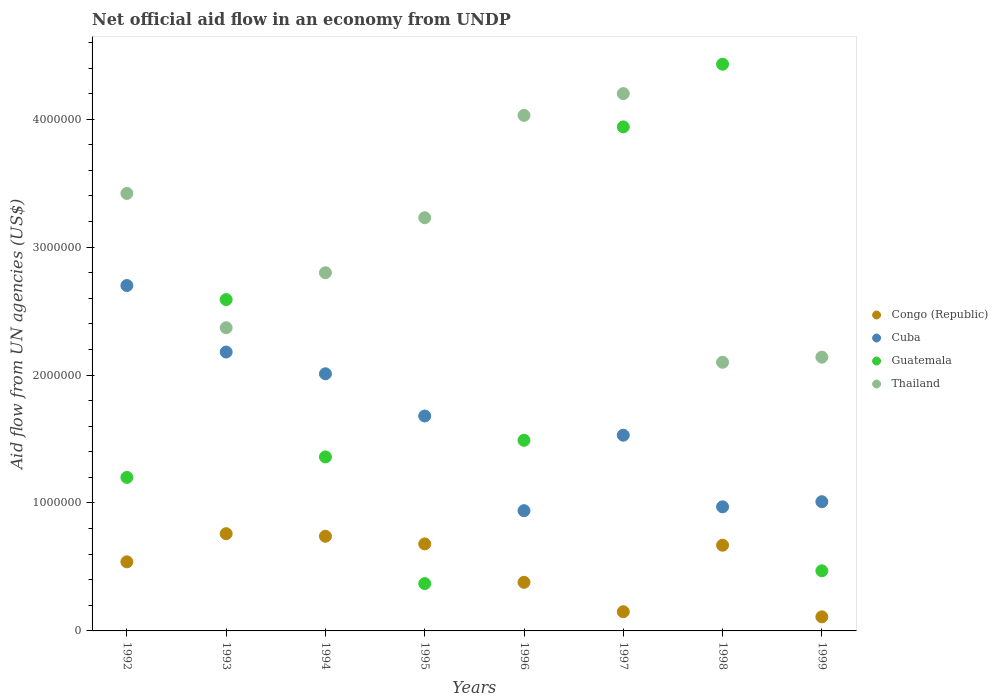How many different coloured dotlines are there?
Your answer should be very brief. 4. What is the net official aid flow in Cuba in 1992?
Offer a very short reply. 2.70e+06. Across all years, what is the maximum net official aid flow in Cuba?
Your answer should be very brief. 2.70e+06. Across all years, what is the minimum net official aid flow in Thailand?
Offer a very short reply. 2.10e+06. In which year was the net official aid flow in Guatemala maximum?
Provide a succinct answer. 1998. What is the total net official aid flow in Guatemala in the graph?
Provide a succinct answer. 1.58e+07. What is the difference between the net official aid flow in Cuba in 1998 and that in 1999?
Ensure brevity in your answer.  -4.00e+04. What is the difference between the net official aid flow in Congo (Republic) in 1992 and the net official aid flow in Thailand in 1997?
Make the answer very short. -3.66e+06. What is the average net official aid flow in Thailand per year?
Your answer should be compact. 3.04e+06. In the year 1993, what is the difference between the net official aid flow in Cuba and net official aid flow in Thailand?
Your answer should be compact. -1.90e+05. What is the ratio of the net official aid flow in Thailand in 1996 to that in 1998?
Provide a succinct answer. 1.92. Is the difference between the net official aid flow in Cuba in 1993 and 1997 greater than the difference between the net official aid flow in Thailand in 1993 and 1997?
Provide a succinct answer. Yes. What is the difference between the highest and the lowest net official aid flow in Guatemala?
Offer a terse response. 4.06e+06. Is it the case that in every year, the sum of the net official aid flow in Cuba and net official aid flow in Congo (Republic)  is greater than the net official aid flow in Thailand?
Offer a very short reply. No. Is the net official aid flow in Guatemala strictly greater than the net official aid flow in Congo (Republic) over the years?
Keep it short and to the point. No. What is the difference between two consecutive major ticks on the Y-axis?
Keep it short and to the point. 1.00e+06. Are the values on the major ticks of Y-axis written in scientific E-notation?
Your answer should be compact. No. Where does the legend appear in the graph?
Keep it short and to the point. Center right. How are the legend labels stacked?
Make the answer very short. Vertical. What is the title of the graph?
Your answer should be very brief. Net official aid flow in an economy from UNDP. What is the label or title of the Y-axis?
Provide a succinct answer. Aid flow from UN agencies (US$). What is the Aid flow from UN agencies (US$) of Congo (Republic) in 1992?
Provide a succinct answer. 5.40e+05. What is the Aid flow from UN agencies (US$) of Cuba in 1992?
Provide a short and direct response. 2.70e+06. What is the Aid flow from UN agencies (US$) of Guatemala in 1992?
Provide a short and direct response. 1.20e+06. What is the Aid flow from UN agencies (US$) in Thailand in 1992?
Your response must be concise. 3.42e+06. What is the Aid flow from UN agencies (US$) in Congo (Republic) in 1993?
Your response must be concise. 7.60e+05. What is the Aid flow from UN agencies (US$) of Cuba in 1993?
Provide a short and direct response. 2.18e+06. What is the Aid flow from UN agencies (US$) in Guatemala in 1993?
Make the answer very short. 2.59e+06. What is the Aid flow from UN agencies (US$) of Thailand in 1993?
Provide a short and direct response. 2.37e+06. What is the Aid flow from UN agencies (US$) in Congo (Republic) in 1994?
Offer a very short reply. 7.40e+05. What is the Aid flow from UN agencies (US$) in Cuba in 1994?
Make the answer very short. 2.01e+06. What is the Aid flow from UN agencies (US$) in Guatemala in 1994?
Provide a short and direct response. 1.36e+06. What is the Aid flow from UN agencies (US$) in Thailand in 1994?
Offer a very short reply. 2.80e+06. What is the Aid flow from UN agencies (US$) in Congo (Republic) in 1995?
Ensure brevity in your answer.  6.80e+05. What is the Aid flow from UN agencies (US$) of Cuba in 1995?
Offer a very short reply. 1.68e+06. What is the Aid flow from UN agencies (US$) of Guatemala in 1995?
Provide a succinct answer. 3.70e+05. What is the Aid flow from UN agencies (US$) of Thailand in 1995?
Provide a short and direct response. 3.23e+06. What is the Aid flow from UN agencies (US$) in Cuba in 1996?
Ensure brevity in your answer.  9.40e+05. What is the Aid flow from UN agencies (US$) of Guatemala in 1996?
Your answer should be compact. 1.49e+06. What is the Aid flow from UN agencies (US$) of Thailand in 1996?
Make the answer very short. 4.03e+06. What is the Aid flow from UN agencies (US$) in Congo (Republic) in 1997?
Offer a terse response. 1.50e+05. What is the Aid flow from UN agencies (US$) in Cuba in 1997?
Offer a very short reply. 1.53e+06. What is the Aid flow from UN agencies (US$) in Guatemala in 1997?
Offer a very short reply. 3.94e+06. What is the Aid flow from UN agencies (US$) in Thailand in 1997?
Ensure brevity in your answer.  4.20e+06. What is the Aid flow from UN agencies (US$) of Congo (Republic) in 1998?
Keep it short and to the point. 6.70e+05. What is the Aid flow from UN agencies (US$) of Cuba in 1998?
Offer a terse response. 9.70e+05. What is the Aid flow from UN agencies (US$) of Guatemala in 1998?
Your answer should be compact. 4.43e+06. What is the Aid flow from UN agencies (US$) of Thailand in 1998?
Your answer should be compact. 2.10e+06. What is the Aid flow from UN agencies (US$) in Cuba in 1999?
Offer a terse response. 1.01e+06. What is the Aid flow from UN agencies (US$) of Guatemala in 1999?
Provide a succinct answer. 4.70e+05. What is the Aid flow from UN agencies (US$) of Thailand in 1999?
Provide a succinct answer. 2.14e+06. Across all years, what is the maximum Aid flow from UN agencies (US$) of Congo (Republic)?
Your answer should be compact. 7.60e+05. Across all years, what is the maximum Aid flow from UN agencies (US$) of Cuba?
Your answer should be very brief. 2.70e+06. Across all years, what is the maximum Aid flow from UN agencies (US$) of Guatemala?
Offer a very short reply. 4.43e+06. Across all years, what is the maximum Aid flow from UN agencies (US$) in Thailand?
Provide a succinct answer. 4.20e+06. Across all years, what is the minimum Aid flow from UN agencies (US$) in Cuba?
Ensure brevity in your answer.  9.40e+05. Across all years, what is the minimum Aid flow from UN agencies (US$) in Thailand?
Your answer should be compact. 2.10e+06. What is the total Aid flow from UN agencies (US$) of Congo (Republic) in the graph?
Keep it short and to the point. 4.03e+06. What is the total Aid flow from UN agencies (US$) of Cuba in the graph?
Provide a succinct answer. 1.30e+07. What is the total Aid flow from UN agencies (US$) of Guatemala in the graph?
Offer a very short reply. 1.58e+07. What is the total Aid flow from UN agencies (US$) in Thailand in the graph?
Keep it short and to the point. 2.43e+07. What is the difference between the Aid flow from UN agencies (US$) in Cuba in 1992 and that in 1993?
Your answer should be very brief. 5.20e+05. What is the difference between the Aid flow from UN agencies (US$) of Guatemala in 1992 and that in 1993?
Provide a short and direct response. -1.39e+06. What is the difference between the Aid flow from UN agencies (US$) of Thailand in 1992 and that in 1993?
Your answer should be very brief. 1.05e+06. What is the difference between the Aid flow from UN agencies (US$) of Cuba in 1992 and that in 1994?
Keep it short and to the point. 6.90e+05. What is the difference between the Aid flow from UN agencies (US$) in Thailand in 1992 and that in 1994?
Keep it short and to the point. 6.20e+05. What is the difference between the Aid flow from UN agencies (US$) in Congo (Republic) in 1992 and that in 1995?
Provide a short and direct response. -1.40e+05. What is the difference between the Aid flow from UN agencies (US$) in Cuba in 1992 and that in 1995?
Your response must be concise. 1.02e+06. What is the difference between the Aid flow from UN agencies (US$) of Guatemala in 1992 and that in 1995?
Provide a short and direct response. 8.30e+05. What is the difference between the Aid flow from UN agencies (US$) in Cuba in 1992 and that in 1996?
Keep it short and to the point. 1.76e+06. What is the difference between the Aid flow from UN agencies (US$) of Thailand in 1992 and that in 1996?
Offer a very short reply. -6.10e+05. What is the difference between the Aid flow from UN agencies (US$) in Congo (Republic) in 1992 and that in 1997?
Your answer should be compact. 3.90e+05. What is the difference between the Aid flow from UN agencies (US$) in Cuba in 1992 and that in 1997?
Give a very brief answer. 1.17e+06. What is the difference between the Aid flow from UN agencies (US$) in Guatemala in 1992 and that in 1997?
Offer a terse response. -2.74e+06. What is the difference between the Aid flow from UN agencies (US$) in Thailand in 1992 and that in 1997?
Offer a very short reply. -7.80e+05. What is the difference between the Aid flow from UN agencies (US$) of Congo (Republic) in 1992 and that in 1998?
Your response must be concise. -1.30e+05. What is the difference between the Aid flow from UN agencies (US$) in Cuba in 1992 and that in 1998?
Keep it short and to the point. 1.73e+06. What is the difference between the Aid flow from UN agencies (US$) in Guatemala in 1992 and that in 1998?
Ensure brevity in your answer.  -3.23e+06. What is the difference between the Aid flow from UN agencies (US$) of Thailand in 1992 and that in 1998?
Your answer should be compact. 1.32e+06. What is the difference between the Aid flow from UN agencies (US$) of Cuba in 1992 and that in 1999?
Your answer should be compact. 1.69e+06. What is the difference between the Aid flow from UN agencies (US$) in Guatemala in 1992 and that in 1999?
Make the answer very short. 7.30e+05. What is the difference between the Aid flow from UN agencies (US$) of Thailand in 1992 and that in 1999?
Provide a succinct answer. 1.28e+06. What is the difference between the Aid flow from UN agencies (US$) of Cuba in 1993 and that in 1994?
Make the answer very short. 1.70e+05. What is the difference between the Aid flow from UN agencies (US$) of Guatemala in 1993 and that in 1994?
Your answer should be very brief. 1.23e+06. What is the difference between the Aid flow from UN agencies (US$) of Thailand in 1993 and that in 1994?
Give a very brief answer. -4.30e+05. What is the difference between the Aid flow from UN agencies (US$) of Congo (Republic) in 1993 and that in 1995?
Make the answer very short. 8.00e+04. What is the difference between the Aid flow from UN agencies (US$) in Cuba in 1993 and that in 1995?
Ensure brevity in your answer.  5.00e+05. What is the difference between the Aid flow from UN agencies (US$) in Guatemala in 1993 and that in 1995?
Offer a terse response. 2.22e+06. What is the difference between the Aid flow from UN agencies (US$) in Thailand in 1993 and that in 1995?
Offer a very short reply. -8.60e+05. What is the difference between the Aid flow from UN agencies (US$) of Congo (Republic) in 1993 and that in 1996?
Make the answer very short. 3.80e+05. What is the difference between the Aid flow from UN agencies (US$) of Cuba in 1993 and that in 1996?
Your answer should be very brief. 1.24e+06. What is the difference between the Aid flow from UN agencies (US$) in Guatemala in 1993 and that in 1996?
Your answer should be compact. 1.10e+06. What is the difference between the Aid flow from UN agencies (US$) in Thailand in 1993 and that in 1996?
Provide a succinct answer. -1.66e+06. What is the difference between the Aid flow from UN agencies (US$) of Cuba in 1993 and that in 1997?
Provide a succinct answer. 6.50e+05. What is the difference between the Aid flow from UN agencies (US$) of Guatemala in 1993 and that in 1997?
Your answer should be compact. -1.35e+06. What is the difference between the Aid flow from UN agencies (US$) of Thailand in 1993 and that in 1997?
Your response must be concise. -1.83e+06. What is the difference between the Aid flow from UN agencies (US$) of Congo (Republic) in 1993 and that in 1998?
Offer a terse response. 9.00e+04. What is the difference between the Aid flow from UN agencies (US$) in Cuba in 1993 and that in 1998?
Offer a very short reply. 1.21e+06. What is the difference between the Aid flow from UN agencies (US$) of Guatemala in 1993 and that in 1998?
Provide a succinct answer. -1.84e+06. What is the difference between the Aid flow from UN agencies (US$) in Thailand in 1993 and that in 1998?
Keep it short and to the point. 2.70e+05. What is the difference between the Aid flow from UN agencies (US$) of Congo (Republic) in 1993 and that in 1999?
Your response must be concise. 6.50e+05. What is the difference between the Aid flow from UN agencies (US$) of Cuba in 1993 and that in 1999?
Provide a short and direct response. 1.17e+06. What is the difference between the Aid flow from UN agencies (US$) of Guatemala in 1993 and that in 1999?
Keep it short and to the point. 2.12e+06. What is the difference between the Aid flow from UN agencies (US$) in Cuba in 1994 and that in 1995?
Give a very brief answer. 3.30e+05. What is the difference between the Aid flow from UN agencies (US$) in Guatemala in 1994 and that in 1995?
Offer a terse response. 9.90e+05. What is the difference between the Aid flow from UN agencies (US$) in Thailand in 1994 and that in 1995?
Offer a terse response. -4.30e+05. What is the difference between the Aid flow from UN agencies (US$) in Cuba in 1994 and that in 1996?
Your answer should be compact. 1.07e+06. What is the difference between the Aid flow from UN agencies (US$) of Thailand in 1994 and that in 1996?
Your answer should be compact. -1.23e+06. What is the difference between the Aid flow from UN agencies (US$) of Congo (Republic) in 1994 and that in 1997?
Ensure brevity in your answer.  5.90e+05. What is the difference between the Aid flow from UN agencies (US$) of Guatemala in 1994 and that in 1997?
Provide a short and direct response. -2.58e+06. What is the difference between the Aid flow from UN agencies (US$) of Thailand in 1994 and that in 1997?
Your answer should be compact. -1.40e+06. What is the difference between the Aid flow from UN agencies (US$) of Cuba in 1994 and that in 1998?
Your response must be concise. 1.04e+06. What is the difference between the Aid flow from UN agencies (US$) in Guatemala in 1994 and that in 1998?
Offer a very short reply. -3.07e+06. What is the difference between the Aid flow from UN agencies (US$) of Thailand in 1994 and that in 1998?
Give a very brief answer. 7.00e+05. What is the difference between the Aid flow from UN agencies (US$) in Congo (Republic) in 1994 and that in 1999?
Offer a terse response. 6.30e+05. What is the difference between the Aid flow from UN agencies (US$) in Guatemala in 1994 and that in 1999?
Make the answer very short. 8.90e+05. What is the difference between the Aid flow from UN agencies (US$) of Congo (Republic) in 1995 and that in 1996?
Make the answer very short. 3.00e+05. What is the difference between the Aid flow from UN agencies (US$) of Cuba in 1995 and that in 1996?
Keep it short and to the point. 7.40e+05. What is the difference between the Aid flow from UN agencies (US$) of Guatemala in 1995 and that in 1996?
Provide a short and direct response. -1.12e+06. What is the difference between the Aid flow from UN agencies (US$) of Thailand in 1995 and that in 1996?
Your answer should be compact. -8.00e+05. What is the difference between the Aid flow from UN agencies (US$) of Congo (Republic) in 1995 and that in 1997?
Keep it short and to the point. 5.30e+05. What is the difference between the Aid flow from UN agencies (US$) of Cuba in 1995 and that in 1997?
Keep it short and to the point. 1.50e+05. What is the difference between the Aid flow from UN agencies (US$) of Guatemala in 1995 and that in 1997?
Your answer should be compact. -3.57e+06. What is the difference between the Aid flow from UN agencies (US$) in Thailand in 1995 and that in 1997?
Provide a succinct answer. -9.70e+05. What is the difference between the Aid flow from UN agencies (US$) in Congo (Republic) in 1995 and that in 1998?
Provide a succinct answer. 10000. What is the difference between the Aid flow from UN agencies (US$) in Cuba in 1995 and that in 1998?
Offer a very short reply. 7.10e+05. What is the difference between the Aid flow from UN agencies (US$) of Guatemala in 1995 and that in 1998?
Your answer should be very brief. -4.06e+06. What is the difference between the Aid flow from UN agencies (US$) of Thailand in 1995 and that in 1998?
Offer a very short reply. 1.13e+06. What is the difference between the Aid flow from UN agencies (US$) of Congo (Republic) in 1995 and that in 1999?
Your answer should be very brief. 5.70e+05. What is the difference between the Aid flow from UN agencies (US$) in Cuba in 1995 and that in 1999?
Your answer should be very brief. 6.70e+05. What is the difference between the Aid flow from UN agencies (US$) of Guatemala in 1995 and that in 1999?
Your answer should be very brief. -1.00e+05. What is the difference between the Aid flow from UN agencies (US$) of Thailand in 1995 and that in 1999?
Your answer should be compact. 1.09e+06. What is the difference between the Aid flow from UN agencies (US$) of Congo (Republic) in 1996 and that in 1997?
Ensure brevity in your answer.  2.30e+05. What is the difference between the Aid flow from UN agencies (US$) in Cuba in 1996 and that in 1997?
Make the answer very short. -5.90e+05. What is the difference between the Aid flow from UN agencies (US$) in Guatemala in 1996 and that in 1997?
Offer a terse response. -2.45e+06. What is the difference between the Aid flow from UN agencies (US$) of Cuba in 1996 and that in 1998?
Give a very brief answer. -3.00e+04. What is the difference between the Aid flow from UN agencies (US$) of Guatemala in 1996 and that in 1998?
Your response must be concise. -2.94e+06. What is the difference between the Aid flow from UN agencies (US$) in Thailand in 1996 and that in 1998?
Offer a very short reply. 1.93e+06. What is the difference between the Aid flow from UN agencies (US$) in Guatemala in 1996 and that in 1999?
Ensure brevity in your answer.  1.02e+06. What is the difference between the Aid flow from UN agencies (US$) in Thailand in 1996 and that in 1999?
Offer a very short reply. 1.89e+06. What is the difference between the Aid flow from UN agencies (US$) of Congo (Republic) in 1997 and that in 1998?
Give a very brief answer. -5.20e+05. What is the difference between the Aid flow from UN agencies (US$) of Cuba in 1997 and that in 1998?
Offer a terse response. 5.60e+05. What is the difference between the Aid flow from UN agencies (US$) of Guatemala in 1997 and that in 1998?
Offer a very short reply. -4.90e+05. What is the difference between the Aid flow from UN agencies (US$) in Thailand in 1997 and that in 1998?
Offer a terse response. 2.10e+06. What is the difference between the Aid flow from UN agencies (US$) in Congo (Republic) in 1997 and that in 1999?
Offer a terse response. 4.00e+04. What is the difference between the Aid flow from UN agencies (US$) of Cuba in 1997 and that in 1999?
Offer a terse response. 5.20e+05. What is the difference between the Aid flow from UN agencies (US$) of Guatemala in 1997 and that in 1999?
Give a very brief answer. 3.47e+06. What is the difference between the Aid flow from UN agencies (US$) of Thailand in 1997 and that in 1999?
Make the answer very short. 2.06e+06. What is the difference between the Aid flow from UN agencies (US$) of Congo (Republic) in 1998 and that in 1999?
Your answer should be compact. 5.60e+05. What is the difference between the Aid flow from UN agencies (US$) of Cuba in 1998 and that in 1999?
Offer a very short reply. -4.00e+04. What is the difference between the Aid flow from UN agencies (US$) in Guatemala in 1998 and that in 1999?
Make the answer very short. 3.96e+06. What is the difference between the Aid flow from UN agencies (US$) of Thailand in 1998 and that in 1999?
Provide a succinct answer. -4.00e+04. What is the difference between the Aid flow from UN agencies (US$) of Congo (Republic) in 1992 and the Aid flow from UN agencies (US$) of Cuba in 1993?
Offer a terse response. -1.64e+06. What is the difference between the Aid flow from UN agencies (US$) of Congo (Republic) in 1992 and the Aid flow from UN agencies (US$) of Guatemala in 1993?
Your answer should be very brief. -2.05e+06. What is the difference between the Aid flow from UN agencies (US$) in Congo (Republic) in 1992 and the Aid flow from UN agencies (US$) in Thailand in 1993?
Give a very brief answer. -1.83e+06. What is the difference between the Aid flow from UN agencies (US$) of Cuba in 1992 and the Aid flow from UN agencies (US$) of Guatemala in 1993?
Your answer should be very brief. 1.10e+05. What is the difference between the Aid flow from UN agencies (US$) of Guatemala in 1992 and the Aid flow from UN agencies (US$) of Thailand in 1993?
Provide a short and direct response. -1.17e+06. What is the difference between the Aid flow from UN agencies (US$) of Congo (Republic) in 1992 and the Aid flow from UN agencies (US$) of Cuba in 1994?
Make the answer very short. -1.47e+06. What is the difference between the Aid flow from UN agencies (US$) in Congo (Republic) in 1992 and the Aid flow from UN agencies (US$) in Guatemala in 1994?
Your answer should be compact. -8.20e+05. What is the difference between the Aid flow from UN agencies (US$) in Congo (Republic) in 1992 and the Aid flow from UN agencies (US$) in Thailand in 1994?
Offer a terse response. -2.26e+06. What is the difference between the Aid flow from UN agencies (US$) of Cuba in 1992 and the Aid flow from UN agencies (US$) of Guatemala in 1994?
Provide a short and direct response. 1.34e+06. What is the difference between the Aid flow from UN agencies (US$) of Guatemala in 1992 and the Aid flow from UN agencies (US$) of Thailand in 1994?
Provide a short and direct response. -1.60e+06. What is the difference between the Aid flow from UN agencies (US$) of Congo (Republic) in 1992 and the Aid flow from UN agencies (US$) of Cuba in 1995?
Offer a terse response. -1.14e+06. What is the difference between the Aid flow from UN agencies (US$) in Congo (Republic) in 1992 and the Aid flow from UN agencies (US$) in Thailand in 1995?
Offer a very short reply. -2.69e+06. What is the difference between the Aid flow from UN agencies (US$) of Cuba in 1992 and the Aid flow from UN agencies (US$) of Guatemala in 1995?
Make the answer very short. 2.33e+06. What is the difference between the Aid flow from UN agencies (US$) in Cuba in 1992 and the Aid flow from UN agencies (US$) in Thailand in 1995?
Give a very brief answer. -5.30e+05. What is the difference between the Aid flow from UN agencies (US$) of Guatemala in 1992 and the Aid flow from UN agencies (US$) of Thailand in 1995?
Your answer should be very brief. -2.03e+06. What is the difference between the Aid flow from UN agencies (US$) of Congo (Republic) in 1992 and the Aid flow from UN agencies (US$) of Cuba in 1996?
Provide a succinct answer. -4.00e+05. What is the difference between the Aid flow from UN agencies (US$) in Congo (Republic) in 1992 and the Aid flow from UN agencies (US$) in Guatemala in 1996?
Your answer should be compact. -9.50e+05. What is the difference between the Aid flow from UN agencies (US$) of Congo (Republic) in 1992 and the Aid flow from UN agencies (US$) of Thailand in 1996?
Provide a succinct answer. -3.49e+06. What is the difference between the Aid flow from UN agencies (US$) in Cuba in 1992 and the Aid flow from UN agencies (US$) in Guatemala in 1996?
Your answer should be very brief. 1.21e+06. What is the difference between the Aid flow from UN agencies (US$) of Cuba in 1992 and the Aid flow from UN agencies (US$) of Thailand in 1996?
Offer a terse response. -1.33e+06. What is the difference between the Aid flow from UN agencies (US$) of Guatemala in 1992 and the Aid flow from UN agencies (US$) of Thailand in 1996?
Offer a very short reply. -2.83e+06. What is the difference between the Aid flow from UN agencies (US$) in Congo (Republic) in 1992 and the Aid flow from UN agencies (US$) in Cuba in 1997?
Offer a very short reply. -9.90e+05. What is the difference between the Aid flow from UN agencies (US$) of Congo (Republic) in 1992 and the Aid flow from UN agencies (US$) of Guatemala in 1997?
Make the answer very short. -3.40e+06. What is the difference between the Aid flow from UN agencies (US$) of Congo (Republic) in 1992 and the Aid flow from UN agencies (US$) of Thailand in 1997?
Your answer should be compact. -3.66e+06. What is the difference between the Aid flow from UN agencies (US$) of Cuba in 1992 and the Aid flow from UN agencies (US$) of Guatemala in 1997?
Ensure brevity in your answer.  -1.24e+06. What is the difference between the Aid flow from UN agencies (US$) in Cuba in 1992 and the Aid flow from UN agencies (US$) in Thailand in 1997?
Ensure brevity in your answer.  -1.50e+06. What is the difference between the Aid flow from UN agencies (US$) in Congo (Republic) in 1992 and the Aid flow from UN agencies (US$) in Cuba in 1998?
Keep it short and to the point. -4.30e+05. What is the difference between the Aid flow from UN agencies (US$) of Congo (Republic) in 1992 and the Aid flow from UN agencies (US$) of Guatemala in 1998?
Your answer should be compact. -3.89e+06. What is the difference between the Aid flow from UN agencies (US$) of Congo (Republic) in 1992 and the Aid flow from UN agencies (US$) of Thailand in 1998?
Offer a terse response. -1.56e+06. What is the difference between the Aid flow from UN agencies (US$) of Cuba in 1992 and the Aid flow from UN agencies (US$) of Guatemala in 1998?
Provide a short and direct response. -1.73e+06. What is the difference between the Aid flow from UN agencies (US$) of Guatemala in 1992 and the Aid flow from UN agencies (US$) of Thailand in 1998?
Make the answer very short. -9.00e+05. What is the difference between the Aid flow from UN agencies (US$) in Congo (Republic) in 1992 and the Aid flow from UN agencies (US$) in Cuba in 1999?
Your answer should be very brief. -4.70e+05. What is the difference between the Aid flow from UN agencies (US$) in Congo (Republic) in 1992 and the Aid flow from UN agencies (US$) in Thailand in 1999?
Offer a very short reply. -1.60e+06. What is the difference between the Aid flow from UN agencies (US$) of Cuba in 1992 and the Aid flow from UN agencies (US$) of Guatemala in 1999?
Your answer should be very brief. 2.23e+06. What is the difference between the Aid flow from UN agencies (US$) in Cuba in 1992 and the Aid flow from UN agencies (US$) in Thailand in 1999?
Your answer should be very brief. 5.60e+05. What is the difference between the Aid flow from UN agencies (US$) of Guatemala in 1992 and the Aid flow from UN agencies (US$) of Thailand in 1999?
Your answer should be very brief. -9.40e+05. What is the difference between the Aid flow from UN agencies (US$) in Congo (Republic) in 1993 and the Aid flow from UN agencies (US$) in Cuba in 1994?
Your answer should be compact. -1.25e+06. What is the difference between the Aid flow from UN agencies (US$) in Congo (Republic) in 1993 and the Aid flow from UN agencies (US$) in Guatemala in 1994?
Give a very brief answer. -6.00e+05. What is the difference between the Aid flow from UN agencies (US$) in Congo (Republic) in 1993 and the Aid flow from UN agencies (US$) in Thailand in 1994?
Offer a very short reply. -2.04e+06. What is the difference between the Aid flow from UN agencies (US$) in Cuba in 1993 and the Aid flow from UN agencies (US$) in Guatemala in 1994?
Provide a succinct answer. 8.20e+05. What is the difference between the Aid flow from UN agencies (US$) in Cuba in 1993 and the Aid flow from UN agencies (US$) in Thailand in 1994?
Give a very brief answer. -6.20e+05. What is the difference between the Aid flow from UN agencies (US$) in Guatemala in 1993 and the Aid flow from UN agencies (US$) in Thailand in 1994?
Provide a succinct answer. -2.10e+05. What is the difference between the Aid flow from UN agencies (US$) in Congo (Republic) in 1993 and the Aid flow from UN agencies (US$) in Cuba in 1995?
Make the answer very short. -9.20e+05. What is the difference between the Aid flow from UN agencies (US$) in Congo (Republic) in 1993 and the Aid flow from UN agencies (US$) in Thailand in 1995?
Your answer should be compact. -2.47e+06. What is the difference between the Aid flow from UN agencies (US$) in Cuba in 1993 and the Aid flow from UN agencies (US$) in Guatemala in 1995?
Provide a succinct answer. 1.81e+06. What is the difference between the Aid flow from UN agencies (US$) of Cuba in 1993 and the Aid flow from UN agencies (US$) of Thailand in 1995?
Make the answer very short. -1.05e+06. What is the difference between the Aid flow from UN agencies (US$) of Guatemala in 1993 and the Aid flow from UN agencies (US$) of Thailand in 1995?
Your answer should be very brief. -6.40e+05. What is the difference between the Aid flow from UN agencies (US$) of Congo (Republic) in 1993 and the Aid flow from UN agencies (US$) of Guatemala in 1996?
Provide a short and direct response. -7.30e+05. What is the difference between the Aid flow from UN agencies (US$) of Congo (Republic) in 1993 and the Aid flow from UN agencies (US$) of Thailand in 1996?
Ensure brevity in your answer.  -3.27e+06. What is the difference between the Aid flow from UN agencies (US$) in Cuba in 1993 and the Aid flow from UN agencies (US$) in Guatemala in 1996?
Your response must be concise. 6.90e+05. What is the difference between the Aid flow from UN agencies (US$) in Cuba in 1993 and the Aid flow from UN agencies (US$) in Thailand in 1996?
Provide a succinct answer. -1.85e+06. What is the difference between the Aid flow from UN agencies (US$) of Guatemala in 1993 and the Aid flow from UN agencies (US$) of Thailand in 1996?
Your response must be concise. -1.44e+06. What is the difference between the Aid flow from UN agencies (US$) of Congo (Republic) in 1993 and the Aid flow from UN agencies (US$) of Cuba in 1997?
Offer a very short reply. -7.70e+05. What is the difference between the Aid flow from UN agencies (US$) in Congo (Republic) in 1993 and the Aid flow from UN agencies (US$) in Guatemala in 1997?
Offer a very short reply. -3.18e+06. What is the difference between the Aid flow from UN agencies (US$) in Congo (Republic) in 1993 and the Aid flow from UN agencies (US$) in Thailand in 1997?
Offer a very short reply. -3.44e+06. What is the difference between the Aid flow from UN agencies (US$) of Cuba in 1993 and the Aid flow from UN agencies (US$) of Guatemala in 1997?
Your answer should be very brief. -1.76e+06. What is the difference between the Aid flow from UN agencies (US$) in Cuba in 1993 and the Aid flow from UN agencies (US$) in Thailand in 1997?
Your response must be concise. -2.02e+06. What is the difference between the Aid flow from UN agencies (US$) in Guatemala in 1993 and the Aid flow from UN agencies (US$) in Thailand in 1997?
Provide a succinct answer. -1.61e+06. What is the difference between the Aid flow from UN agencies (US$) in Congo (Republic) in 1993 and the Aid flow from UN agencies (US$) in Guatemala in 1998?
Ensure brevity in your answer.  -3.67e+06. What is the difference between the Aid flow from UN agencies (US$) in Congo (Republic) in 1993 and the Aid flow from UN agencies (US$) in Thailand in 1998?
Offer a terse response. -1.34e+06. What is the difference between the Aid flow from UN agencies (US$) in Cuba in 1993 and the Aid flow from UN agencies (US$) in Guatemala in 1998?
Provide a succinct answer. -2.25e+06. What is the difference between the Aid flow from UN agencies (US$) of Cuba in 1993 and the Aid flow from UN agencies (US$) of Thailand in 1998?
Make the answer very short. 8.00e+04. What is the difference between the Aid flow from UN agencies (US$) of Guatemala in 1993 and the Aid flow from UN agencies (US$) of Thailand in 1998?
Offer a terse response. 4.90e+05. What is the difference between the Aid flow from UN agencies (US$) in Congo (Republic) in 1993 and the Aid flow from UN agencies (US$) in Cuba in 1999?
Provide a succinct answer. -2.50e+05. What is the difference between the Aid flow from UN agencies (US$) in Congo (Republic) in 1993 and the Aid flow from UN agencies (US$) in Guatemala in 1999?
Give a very brief answer. 2.90e+05. What is the difference between the Aid flow from UN agencies (US$) in Congo (Republic) in 1993 and the Aid flow from UN agencies (US$) in Thailand in 1999?
Provide a succinct answer. -1.38e+06. What is the difference between the Aid flow from UN agencies (US$) of Cuba in 1993 and the Aid flow from UN agencies (US$) of Guatemala in 1999?
Give a very brief answer. 1.71e+06. What is the difference between the Aid flow from UN agencies (US$) of Congo (Republic) in 1994 and the Aid flow from UN agencies (US$) of Cuba in 1995?
Provide a succinct answer. -9.40e+05. What is the difference between the Aid flow from UN agencies (US$) of Congo (Republic) in 1994 and the Aid flow from UN agencies (US$) of Guatemala in 1995?
Your answer should be very brief. 3.70e+05. What is the difference between the Aid flow from UN agencies (US$) of Congo (Republic) in 1994 and the Aid flow from UN agencies (US$) of Thailand in 1995?
Ensure brevity in your answer.  -2.49e+06. What is the difference between the Aid flow from UN agencies (US$) in Cuba in 1994 and the Aid flow from UN agencies (US$) in Guatemala in 1995?
Provide a short and direct response. 1.64e+06. What is the difference between the Aid flow from UN agencies (US$) of Cuba in 1994 and the Aid flow from UN agencies (US$) of Thailand in 1995?
Keep it short and to the point. -1.22e+06. What is the difference between the Aid flow from UN agencies (US$) in Guatemala in 1994 and the Aid flow from UN agencies (US$) in Thailand in 1995?
Offer a terse response. -1.87e+06. What is the difference between the Aid flow from UN agencies (US$) in Congo (Republic) in 1994 and the Aid flow from UN agencies (US$) in Guatemala in 1996?
Offer a terse response. -7.50e+05. What is the difference between the Aid flow from UN agencies (US$) in Congo (Republic) in 1994 and the Aid flow from UN agencies (US$) in Thailand in 1996?
Your response must be concise. -3.29e+06. What is the difference between the Aid flow from UN agencies (US$) in Cuba in 1994 and the Aid flow from UN agencies (US$) in Guatemala in 1996?
Ensure brevity in your answer.  5.20e+05. What is the difference between the Aid flow from UN agencies (US$) of Cuba in 1994 and the Aid flow from UN agencies (US$) of Thailand in 1996?
Your response must be concise. -2.02e+06. What is the difference between the Aid flow from UN agencies (US$) of Guatemala in 1994 and the Aid flow from UN agencies (US$) of Thailand in 1996?
Offer a terse response. -2.67e+06. What is the difference between the Aid flow from UN agencies (US$) in Congo (Republic) in 1994 and the Aid flow from UN agencies (US$) in Cuba in 1997?
Offer a terse response. -7.90e+05. What is the difference between the Aid flow from UN agencies (US$) in Congo (Republic) in 1994 and the Aid flow from UN agencies (US$) in Guatemala in 1997?
Make the answer very short. -3.20e+06. What is the difference between the Aid flow from UN agencies (US$) in Congo (Republic) in 1994 and the Aid flow from UN agencies (US$) in Thailand in 1997?
Keep it short and to the point. -3.46e+06. What is the difference between the Aid flow from UN agencies (US$) in Cuba in 1994 and the Aid flow from UN agencies (US$) in Guatemala in 1997?
Keep it short and to the point. -1.93e+06. What is the difference between the Aid flow from UN agencies (US$) in Cuba in 1994 and the Aid flow from UN agencies (US$) in Thailand in 1997?
Ensure brevity in your answer.  -2.19e+06. What is the difference between the Aid flow from UN agencies (US$) of Guatemala in 1994 and the Aid flow from UN agencies (US$) of Thailand in 1997?
Your response must be concise. -2.84e+06. What is the difference between the Aid flow from UN agencies (US$) of Congo (Republic) in 1994 and the Aid flow from UN agencies (US$) of Cuba in 1998?
Provide a succinct answer. -2.30e+05. What is the difference between the Aid flow from UN agencies (US$) of Congo (Republic) in 1994 and the Aid flow from UN agencies (US$) of Guatemala in 1998?
Your response must be concise. -3.69e+06. What is the difference between the Aid flow from UN agencies (US$) in Congo (Republic) in 1994 and the Aid flow from UN agencies (US$) in Thailand in 1998?
Offer a very short reply. -1.36e+06. What is the difference between the Aid flow from UN agencies (US$) of Cuba in 1994 and the Aid flow from UN agencies (US$) of Guatemala in 1998?
Keep it short and to the point. -2.42e+06. What is the difference between the Aid flow from UN agencies (US$) in Guatemala in 1994 and the Aid flow from UN agencies (US$) in Thailand in 1998?
Your answer should be compact. -7.40e+05. What is the difference between the Aid flow from UN agencies (US$) of Congo (Republic) in 1994 and the Aid flow from UN agencies (US$) of Cuba in 1999?
Provide a short and direct response. -2.70e+05. What is the difference between the Aid flow from UN agencies (US$) in Congo (Republic) in 1994 and the Aid flow from UN agencies (US$) in Thailand in 1999?
Ensure brevity in your answer.  -1.40e+06. What is the difference between the Aid flow from UN agencies (US$) of Cuba in 1994 and the Aid flow from UN agencies (US$) of Guatemala in 1999?
Make the answer very short. 1.54e+06. What is the difference between the Aid flow from UN agencies (US$) in Guatemala in 1994 and the Aid flow from UN agencies (US$) in Thailand in 1999?
Your response must be concise. -7.80e+05. What is the difference between the Aid flow from UN agencies (US$) in Congo (Republic) in 1995 and the Aid flow from UN agencies (US$) in Cuba in 1996?
Your answer should be compact. -2.60e+05. What is the difference between the Aid flow from UN agencies (US$) of Congo (Republic) in 1995 and the Aid flow from UN agencies (US$) of Guatemala in 1996?
Ensure brevity in your answer.  -8.10e+05. What is the difference between the Aid flow from UN agencies (US$) of Congo (Republic) in 1995 and the Aid flow from UN agencies (US$) of Thailand in 1996?
Ensure brevity in your answer.  -3.35e+06. What is the difference between the Aid flow from UN agencies (US$) of Cuba in 1995 and the Aid flow from UN agencies (US$) of Thailand in 1996?
Provide a short and direct response. -2.35e+06. What is the difference between the Aid flow from UN agencies (US$) of Guatemala in 1995 and the Aid flow from UN agencies (US$) of Thailand in 1996?
Offer a terse response. -3.66e+06. What is the difference between the Aid flow from UN agencies (US$) of Congo (Republic) in 1995 and the Aid flow from UN agencies (US$) of Cuba in 1997?
Your response must be concise. -8.50e+05. What is the difference between the Aid flow from UN agencies (US$) of Congo (Republic) in 1995 and the Aid flow from UN agencies (US$) of Guatemala in 1997?
Offer a terse response. -3.26e+06. What is the difference between the Aid flow from UN agencies (US$) of Congo (Republic) in 1995 and the Aid flow from UN agencies (US$) of Thailand in 1997?
Provide a short and direct response. -3.52e+06. What is the difference between the Aid flow from UN agencies (US$) of Cuba in 1995 and the Aid flow from UN agencies (US$) of Guatemala in 1997?
Your answer should be compact. -2.26e+06. What is the difference between the Aid flow from UN agencies (US$) in Cuba in 1995 and the Aid flow from UN agencies (US$) in Thailand in 1997?
Offer a very short reply. -2.52e+06. What is the difference between the Aid flow from UN agencies (US$) of Guatemala in 1995 and the Aid flow from UN agencies (US$) of Thailand in 1997?
Offer a very short reply. -3.83e+06. What is the difference between the Aid flow from UN agencies (US$) in Congo (Republic) in 1995 and the Aid flow from UN agencies (US$) in Cuba in 1998?
Offer a very short reply. -2.90e+05. What is the difference between the Aid flow from UN agencies (US$) in Congo (Republic) in 1995 and the Aid flow from UN agencies (US$) in Guatemala in 1998?
Provide a short and direct response. -3.75e+06. What is the difference between the Aid flow from UN agencies (US$) of Congo (Republic) in 1995 and the Aid flow from UN agencies (US$) of Thailand in 1998?
Give a very brief answer. -1.42e+06. What is the difference between the Aid flow from UN agencies (US$) of Cuba in 1995 and the Aid flow from UN agencies (US$) of Guatemala in 1998?
Keep it short and to the point. -2.75e+06. What is the difference between the Aid flow from UN agencies (US$) of Cuba in 1995 and the Aid flow from UN agencies (US$) of Thailand in 1998?
Provide a short and direct response. -4.20e+05. What is the difference between the Aid flow from UN agencies (US$) of Guatemala in 1995 and the Aid flow from UN agencies (US$) of Thailand in 1998?
Your answer should be compact. -1.73e+06. What is the difference between the Aid flow from UN agencies (US$) of Congo (Republic) in 1995 and the Aid flow from UN agencies (US$) of Cuba in 1999?
Your answer should be compact. -3.30e+05. What is the difference between the Aid flow from UN agencies (US$) of Congo (Republic) in 1995 and the Aid flow from UN agencies (US$) of Guatemala in 1999?
Keep it short and to the point. 2.10e+05. What is the difference between the Aid flow from UN agencies (US$) in Congo (Republic) in 1995 and the Aid flow from UN agencies (US$) in Thailand in 1999?
Your answer should be very brief. -1.46e+06. What is the difference between the Aid flow from UN agencies (US$) in Cuba in 1995 and the Aid flow from UN agencies (US$) in Guatemala in 1999?
Make the answer very short. 1.21e+06. What is the difference between the Aid flow from UN agencies (US$) of Cuba in 1995 and the Aid flow from UN agencies (US$) of Thailand in 1999?
Your answer should be compact. -4.60e+05. What is the difference between the Aid flow from UN agencies (US$) in Guatemala in 1995 and the Aid flow from UN agencies (US$) in Thailand in 1999?
Your answer should be compact. -1.77e+06. What is the difference between the Aid flow from UN agencies (US$) of Congo (Republic) in 1996 and the Aid flow from UN agencies (US$) of Cuba in 1997?
Offer a very short reply. -1.15e+06. What is the difference between the Aid flow from UN agencies (US$) of Congo (Republic) in 1996 and the Aid flow from UN agencies (US$) of Guatemala in 1997?
Give a very brief answer. -3.56e+06. What is the difference between the Aid flow from UN agencies (US$) of Congo (Republic) in 1996 and the Aid flow from UN agencies (US$) of Thailand in 1997?
Offer a very short reply. -3.82e+06. What is the difference between the Aid flow from UN agencies (US$) of Cuba in 1996 and the Aid flow from UN agencies (US$) of Thailand in 1997?
Your answer should be very brief. -3.26e+06. What is the difference between the Aid flow from UN agencies (US$) of Guatemala in 1996 and the Aid flow from UN agencies (US$) of Thailand in 1997?
Provide a short and direct response. -2.71e+06. What is the difference between the Aid flow from UN agencies (US$) in Congo (Republic) in 1996 and the Aid flow from UN agencies (US$) in Cuba in 1998?
Your answer should be very brief. -5.90e+05. What is the difference between the Aid flow from UN agencies (US$) of Congo (Republic) in 1996 and the Aid flow from UN agencies (US$) of Guatemala in 1998?
Give a very brief answer. -4.05e+06. What is the difference between the Aid flow from UN agencies (US$) of Congo (Republic) in 1996 and the Aid flow from UN agencies (US$) of Thailand in 1998?
Ensure brevity in your answer.  -1.72e+06. What is the difference between the Aid flow from UN agencies (US$) in Cuba in 1996 and the Aid flow from UN agencies (US$) in Guatemala in 1998?
Your answer should be very brief. -3.49e+06. What is the difference between the Aid flow from UN agencies (US$) of Cuba in 1996 and the Aid flow from UN agencies (US$) of Thailand in 1998?
Provide a short and direct response. -1.16e+06. What is the difference between the Aid flow from UN agencies (US$) in Guatemala in 1996 and the Aid flow from UN agencies (US$) in Thailand in 1998?
Give a very brief answer. -6.10e+05. What is the difference between the Aid flow from UN agencies (US$) in Congo (Republic) in 1996 and the Aid flow from UN agencies (US$) in Cuba in 1999?
Ensure brevity in your answer.  -6.30e+05. What is the difference between the Aid flow from UN agencies (US$) of Congo (Republic) in 1996 and the Aid flow from UN agencies (US$) of Guatemala in 1999?
Make the answer very short. -9.00e+04. What is the difference between the Aid flow from UN agencies (US$) in Congo (Republic) in 1996 and the Aid flow from UN agencies (US$) in Thailand in 1999?
Your answer should be compact. -1.76e+06. What is the difference between the Aid flow from UN agencies (US$) in Cuba in 1996 and the Aid flow from UN agencies (US$) in Thailand in 1999?
Provide a short and direct response. -1.20e+06. What is the difference between the Aid flow from UN agencies (US$) in Guatemala in 1996 and the Aid flow from UN agencies (US$) in Thailand in 1999?
Give a very brief answer. -6.50e+05. What is the difference between the Aid flow from UN agencies (US$) in Congo (Republic) in 1997 and the Aid flow from UN agencies (US$) in Cuba in 1998?
Provide a short and direct response. -8.20e+05. What is the difference between the Aid flow from UN agencies (US$) of Congo (Republic) in 1997 and the Aid flow from UN agencies (US$) of Guatemala in 1998?
Offer a terse response. -4.28e+06. What is the difference between the Aid flow from UN agencies (US$) of Congo (Republic) in 1997 and the Aid flow from UN agencies (US$) of Thailand in 1998?
Provide a short and direct response. -1.95e+06. What is the difference between the Aid flow from UN agencies (US$) of Cuba in 1997 and the Aid flow from UN agencies (US$) of Guatemala in 1998?
Make the answer very short. -2.90e+06. What is the difference between the Aid flow from UN agencies (US$) in Cuba in 1997 and the Aid flow from UN agencies (US$) in Thailand in 1998?
Your response must be concise. -5.70e+05. What is the difference between the Aid flow from UN agencies (US$) of Guatemala in 1997 and the Aid flow from UN agencies (US$) of Thailand in 1998?
Provide a succinct answer. 1.84e+06. What is the difference between the Aid flow from UN agencies (US$) in Congo (Republic) in 1997 and the Aid flow from UN agencies (US$) in Cuba in 1999?
Provide a succinct answer. -8.60e+05. What is the difference between the Aid flow from UN agencies (US$) of Congo (Republic) in 1997 and the Aid flow from UN agencies (US$) of Guatemala in 1999?
Your answer should be compact. -3.20e+05. What is the difference between the Aid flow from UN agencies (US$) of Congo (Republic) in 1997 and the Aid flow from UN agencies (US$) of Thailand in 1999?
Give a very brief answer. -1.99e+06. What is the difference between the Aid flow from UN agencies (US$) of Cuba in 1997 and the Aid flow from UN agencies (US$) of Guatemala in 1999?
Your answer should be compact. 1.06e+06. What is the difference between the Aid flow from UN agencies (US$) of Cuba in 1997 and the Aid flow from UN agencies (US$) of Thailand in 1999?
Provide a succinct answer. -6.10e+05. What is the difference between the Aid flow from UN agencies (US$) in Guatemala in 1997 and the Aid flow from UN agencies (US$) in Thailand in 1999?
Keep it short and to the point. 1.80e+06. What is the difference between the Aid flow from UN agencies (US$) in Congo (Republic) in 1998 and the Aid flow from UN agencies (US$) in Thailand in 1999?
Your response must be concise. -1.47e+06. What is the difference between the Aid flow from UN agencies (US$) of Cuba in 1998 and the Aid flow from UN agencies (US$) of Guatemala in 1999?
Your answer should be compact. 5.00e+05. What is the difference between the Aid flow from UN agencies (US$) of Cuba in 1998 and the Aid flow from UN agencies (US$) of Thailand in 1999?
Offer a very short reply. -1.17e+06. What is the difference between the Aid flow from UN agencies (US$) of Guatemala in 1998 and the Aid flow from UN agencies (US$) of Thailand in 1999?
Ensure brevity in your answer.  2.29e+06. What is the average Aid flow from UN agencies (US$) of Congo (Republic) per year?
Make the answer very short. 5.04e+05. What is the average Aid flow from UN agencies (US$) in Cuba per year?
Provide a short and direct response. 1.63e+06. What is the average Aid flow from UN agencies (US$) in Guatemala per year?
Your response must be concise. 1.98e+06. What is the average Aid flow from UN agencies (US$) of Thailand per year?
Offer a very short reply. 3.04e+06. In the year 1992, what is the difference between the Aid flow from UN agencies (US$) of Congo (Republic) and Aid flow from UN agencies (US$) of Cuba?
Your answer should be compact. -2.16e+06. In the year 1992, what is the difference between the Aid flow from UN agencies (US$) of Congo (Republic) and Aid flow from UN agencies (US$) of Guatemala?
Make the answer very short. -6.60e+05. In the year 1992, what is the difference between the Aid flow from UN agencies (US$) of Congo (Republic) and Aid flow from UN agencies (US$) of Thailand?
Provide a succinct answer. -2.88e+06. In the year 1992, what is the difference between the Aid flow from UN agencies (US$) in Cuba and Aid flow from UN agencies (US$) in Guatemala?
Your answer should be compact. 1.50e+06. In the year 1992, what is the difference between the Aid flow from UN agencies (US$) in Cuba and Aid flow from UN agencies (US$) in Thailand?
Offer a very short reply. -7.20e+05. In the year 1992, what is the difference between the Aid flow from UN agencies (US$) in Guatemala and Aid flow from UN agencies (US$) in Thailand?
Make the answer very short. -2.22e+06. In the year 1993, what is the difference between the Aid flow from UN agencies (US$) in Congo (Republic) and Aid flow from UN agencies (US$) in Cuba?
Your response must be concise. -1.42e+06. In the year 1993, what is the difference between the Aid flow from UN agencies (US$) of Congo (Republic) and Aid flow from UN agencies (US$) of Guatemala?
Provide a succinct answer. -1.83e+06. In the year 1993, what is the difference between the Aid flow from UN agencies (US$) of Congo (Republic) and Aid flow from UN agencies (US$) of Thailand?
Offer a terse response. -1.61e+06. In the year 1993, what is the difference between the Aid flow from UN agencies (US$) in Cuba and Aid flow from UN agencies (US$) in Guatemala?
Ensure brevity in your answer.  -4.10e+05. In the year 1993, what is the difference between the Aid flow from UN agencies (US$) in Cuba and Aid flow from UN agencies (US$) in Thailand?
Make the answer very short. -1.90e+05. In the year 1993, what is the difference between the Aid flow from UN agencies (US$) of Guatemala and Aid flow from UN agencies (US$) of Thailand?
Make the answer very short. 2.20e+05. In the year 1994, what is the difference between the Aid flow from UN agencies (US$) in Congo (Republic) and Aid flow from UN agencies (US$) in Cuba?
Your answer should be very brief. -1.27e+06. In the year 1994, what is the difference between the Aid flow from UN agencies (US$) of Congo (Republic) and Aid flow from UN agencies (US$) of Guatemala?
Provide a short and direct response. -6.20e+05. In the year 1994, what is the difference between the Aid flow from UN agencies (US$) in Congo (Republic) and Aid flow from UN agencies (US$) in Thailand?
Your answer should be compact. -2.06e+06. In the year 1994, what is the difference between the Aid flow from UN agencies (US$) of Cuba and Aid flow from UN agencies (US$) of Guatemala?
Ensure brevity in your answer.  6.50e+05. In the year 1994, what is the difference between the Aid flow from UN agencies (US$) of Cuba and Aid flow from UN agencies (US$) of Thailand?
Offer a terse response. -7.90e+05. In the year 1994, what is the difference between the Aid flow from UN agencies (US$) in Guatemala and Aid flow from UN agencies (US$) in Thailand?
Offer a terse response. -1.44e+06. In the year 1995, what is the difference between the Aid flow from UN agencies (US$) of Congo (Republic) and Aid flow from UN agencies (US$) of Guatemala?
Keep it short and to the point. 3.10e+05. In the year 1995, what is the difference between the Aid flow from UN agencies (US$) of Congo (Republic) and Aid flow from UN agencies (US$) of Thailand?
Provide a short and direct response. -2.55e+06. In the year 1995, what is the difference between the Aid flow from UN agencies (US$) in Cuba and Aid flow from UN agencies (US$) in Guatemala?
Provide a short and direct response. 1.31e+06. In the year 1995, what is the difference between the Aid flow from UN agencies (US$) of Cuba and Aid flow from UN agencies (US$) of Thailand?
Offer a very short reply. -1.55e+06. In the year 1995, what is the difference between the Aid flow from UN agencies (US$) of Guatemala and Aid flow from UN agencies (US$) of Thailand?
Provide a succinct answer. -2.86e+06. In the year 1996, what is the difference between the Aid flow from UN agencies (US$) of Congo (Republic) and Aid flow from UN agencies (US$) of Cuba?
Give a very brief answer. -5.60e+05. In the year 1996, what is the difference between the Aid flow from UN agencies (US$) of Congo (Republic) and Aid flow from UN agencies (US$) of Guatemala?
Your response must be concise. -1.11e+06. In the year 1996, what is the difference between the Aid flow from UN agencies (US$) in Congo (Republic) and Aid flow from UN agencies (US$) in Thailand?
Offer a very short reply. -3.65e+06. In the year 1996, what is the difference between the Aid flow from UN agencies (US$) of Cuba and Aid flow from UN agencies (US$) of Guatemala?
Provide a succinct answer. -5.50e+05. In the year 1996, what is the difference between the Aid flow from UN agencies (US$) of Cuba and Aid flow from UN agencies (US$) of Thailand?
Keep it short and to the point. -3.09e+06. In the year 1996, what is the difference between the Aid flow from UN agencies (US$) in Guatemala and Aid flow from UN agencies (US$) in Thailand?
Your answer should be very brief. -2.54e+06. In the year 1997, what is the difference between the Aid flow from UN agencies (US$) of Congo (Republic) and Aid flow from UN agencies (US$) of Cuba?
Give a very brief answer. -1.38e+06. In the year 1997, what is the difference between the Aid flow from UN agencies (US$) in Congo (Republic) and Aid flow from UN agencies (US$) in Guatemala?
Provide a short and direct response. -3.79e+06. In the year 1997, what is the difference between the Aid flow from UN agencies (US$) in Congo (Republic) and Aid flow from UN agencies (US$) in Thailand?
Keep it short and to the point. -4.05e+06. In the year 1997, what is the difference between the Aid flow from UN agencies (US$) in Cuba and Aid flow from UN agencies (US$) in Guatemala?
Give a very brief answer. -2.41e+06. In the year 1997, what is the difference between the Aid flow from UN agencies (US$) of Cuba and Aid flow from UN agencies (US$) of Thailand?
Ensure brevity in your answer.  -2.67e+06. In the year 1997, what is the difference between the Aid flow from UN agencies (US$) in Guatemala and Aid flow from UN agencies (US$) in Thailand?
Provide a succinct answer. -2.60e+05. In the year 1998, what is the difference between the Aid flow from UN agencies (US$) in Congo (Republic) and Aid flow from UN agencies (US$) in Guatemala?
Offer a terse response. -3.76e+06. In the year 1998, what is the difference between the Aid flow from UN agencies (US$) in Congo (Republic) and Aid flow from UN agencies (US$) in Thailand?
Give a very brief answer. -1.43e+06. In the year 1998, what is the difference between the Aid flow from UN agencies (US$) in Cuba and Aid flow from UN agencies (US$) in Guatemala?
Your answer should be very brief. -3.46e+06. In the year 1998, what is the difference between the Aid flow from UN agencies (US$) of Cuba and Aid flow from UN agencies (US$) of Thailand?
Keep it short and to the point. -1.13e+06. In the year 1998, what is the difference between the Aid flow from UN agencies (US$) in Guatemala and Aid flow from UN agencies (US$) in Thailand?
Keep it short and to the point. 2.33e+06. In the year 1999, what is the difference between the Aid flow from UN agencies (US$) in Congo (Republic) and Aid flow from UN agencies (US$) in Cuba?
Your answer should be compact. -9.00e+05. In the year 1999, what is the difference between the Aid flow from UN agencies (US$) in Congo (Republic) and Aid flow from UN agencies (US$) in Guatemala?
Your answer should be very brief. -3.60e+05. In the year 1999, what is the difference between the Aid flow from UN agencies (US$) of Congo (Republic) and Aid flow from UN agencies (US$) of Thailand?
Your answer should be compact. -2.03e+06. In the year 1999, what is the difference between the Aid flow from UN agencies (US$) of Cuba and Aid flow from UN agencies (US$) of Guatemala?
Your response must be concise. 5.40e+05. In the year 1999, what is the difference between the Aid flow from UN agencies (US$) in Cuba and Aid flow from UN agencies (US$) in Thailand?
Provide a succinct answer. -1.13e+06. In the year 1999, what is the difference between the Aid flow from UN agencies (US$) in Guatemala and Aid flow from UN agencies (US$) in Thailand?
Provide a short and direct response. -1.67e+06. What is the ratio of the Aid flow from UN agencies (US$) of Congo (Republic) in 1992 to that in 1993?
Ensure brevity in your answer.  0.71. What is the ratio of the Aid flow from UN agencies (US$) of Cuba in 1992 to that in 1993?
Keep it short and to the point. 1.24. What is the ratio of the Aid flow from UN agencies (US$) in Guatemala in 1992 to that in 1993?
Your answer should be very brief. 0.46. What is the ratio of the Aid flow from UN agencies (US$) in Thailand in 1992 to that in 1993?
Keep it short and to the point. 1.44. What is the ratio of the Aid flow from UN agencies (US$) of Congo (Republic) in 1992 to that in 1994?
Give a very brief answer. 0.73. What is the ratio of the Aid flow from UN agencies (US$) in Cuba in 1992 to that in 1994?
Your answer should be compact. 1.34. What is the ratio of the Aid flow from UN agencies (US$) in Guatemala in 1992 to that in 1994?
Make the answer very short. 0.88. What is the ratio of the Aid flow from UN agencies (US$) in Thailand in 1992 to that in 1994?
Offer a terse response. 1.22. What is the ratio of the Aid flow from UN agencies (US$) in Congo (Republic) in 1992 to that in 1995?
Your answer should be very brief. 0.79. What is the ratio of the Aid flow from UN agencies (US$) in Cuba in 1992 to that in 1995?
Make the answer very short. 1.61. What is the ratio of the Aid flow from UN agencies (US$) of Guatemala in 1992 to that in 1995?
Provide a short and direct response. 3.24. What is the ratio of the Aid flow from UN agencies (US$) of Thailand in 1992 to that in 1995?
Make the answer very short. 1.06. What is the ratio of the Aid flow from UN agencies (US$) in Congo (Republic) in 1992 to that in 1996?
Provide a succinct answer. 1.42. What is the ratio of the Aid flow from UN agencies (US$) in Cuba in 1992 to that in 1996?
Keep it short and to the point. 2.87. What is the ratio of the Aid flow from UN agencies (US$) in Guatemala in 1992 to that in 1996?
Your answer should be compact. 0.81. What is the ratio of the Aid flow from UN agencies (US$) of Thailand in 1992 to that in 1996?
Offer a terse response. 0.85. What is the ratio of the Aid flow from UN agencies (US$) of Congo (Republic) in 1992 to that in 1997?
Keep it short and to the point. 3.6. What is the ratio of the Aid flow from UN agencies (US$) of Cuba in 1992 to that in 1997?
Ensure brevity in your answer.  1.76. What is the ratio of the Aid flow from UN agencies (US$) in Guatemala in 1992 to that in 1997?
Keep it short and to the point. 0.3. What is the ratio of the Aid flow from UN agencies (US$) in Thailand in 1992 to that in 1997?
Give a very brief answer. 0.81. What is the ratio of the Aid flow from UN agencies (US$) in Congo (Republic) in 1992 to that in 1998?
Make the answer very short. 0.81. What is the ratio of the Aid flow from UN agencies (US$) of Cuba in 1992 to that in 1998?
Your answer should be compact. 2.78. What is the ratio of the Aid flow from UN agencies (US$) of Guatemala in 1992 to that in 1998?
Ensure brevity in your answer.  0.27. What is the ratio of the Aid flow from UN agencies (US$) in Thailand in 1992 to that in 1998?
Your response must be concise. 1.63. What is the ratio of the Aid flow from UN agencies (US$) of Congo (Republic) in 1992 to that in 1999?
Offer a very short reply. 4.91. What is the ratio of the Aid flow from UN agencies (US$) in Cuba in 1992 to that in 1999?
Your answer should be very brief. 2.67. What is the ratio of the Aid flow from UN agencies (US$) in Guatemala in 1992 to that in 1999?
Your answer should be compact. 2.55. What is the ratio of the Aid flow from UN agencies (US$) in Thailand in 1992 to that in 1999?
Provide a short and direct response. 1.6. What is the ratio of the Aid flow from UN agencies (US$) in Cuba in 1993 to that in 1994?
Provide a succinct answer. 1.08. What is the ratio of the Aid flow from UN agencies (US$) of Guatemala in 1993 to that in 1994?
Keep it short and to the point. 1.9. What is the ratio of the Aid flow from UN agencies (US$) of Thailand in 1993 to that in 1994?
Provide a succinct answer. 0.85. What is the ratio of the Aid flow from UN agencies (US$) of Congo (Republic) in 1993 to that in 1995?
Your answer should be compact. 1.12. What is the ratio of the Aid flow from UN agencies (US$) in Cuba in 1993 to that in 1995?
Your answer should be very brief. 1.3. What is the ratio of the Aid flow from UN agencies (US$) of Thailand in 1993 to that in 1995?
Offer a very short reply. 0.73. What is the ratio of the Aid flow from UN agencies (US$) of Cuba in 1993 to that in 1996?
Keep it short and to the point. 2.32. What is the ratio of the Aid flow from UN agencies (US$) in Guatemala in 1993 to that in 1996?
Offer a terse response. 1.74. What is the ratio of the Aid flow from UN agencies (US$) of Thailand in 1993 to that in 1996?
Provide a short and direct response. 0.59. What is the ratio of the Aid flow from UN agencies (US$) in Congo (Republic) in 1993 to that in 1997?
Provide a succinct answer. 5.07. What is the ratio of the Aid flow from UN agencies (US$) in Cuba in 1993 to that in 1997?
Offer a very short reply. 1.42. What is the ratio of the Aid flow from UN agencies (US$) in Guatemala in 1993 to that in 1997?
Your response must be concise. 0.66. What is the ratio of the Aid flow from UN agencies (US$) of Thailand in 1993 to that in 1997?
Your answer should be very brief. 0.56. What is the ratio of the Aid flow from UN agencies (US$) of Congo (Republic) in 1993 to that in 1998?
Ensure brevity in your answer.  1.13. What is the ratio of the Aid flow from UN agencies (US$) of Cuba in 1993 to that in 1998?
Offer a terse response. 2.25. What is the ratio of the Aid flow from UN agencies (US$) in Guatemala in 1993 to that in 1998?
Offer a terse response. 0.58. What is the ratio of the Aid flow from UN agencies (US$) in Thailand in 1993 to that in 1998?
Your answer should be compact. 1.13. What is the ratio of the Aid flow from UN agencies (US$) of Congo (Republic) in 1993 to that in 1999?
Keep it short and to the point. 6.91. What is the ratio of the Aid flow from UN agencies (US$) in Cuba in 1993 to that in 1999?
Your response must be concise. 2.16. What is the ratio of the Aid flow from UN agencies (US$) in Guatemala in 1993 to that in 1999?
Give a very brief answer. 5.51. What is the ratio of the Aid flow from UN agencies (US$) of Thailand in 1993 to that in 1999?
Give a very brief answer. 1.11. What is the ratio of the Aid flow from UN agencies (US$) of Congo (Republic) in 1994 to that in 1995?
Offer a terse response. 1.09. What is the ratio of the Aid flow from UN agencies (US$) of Cuba in 1994 to that in 1995?
Give a very brief answer. 1.2. What is the ratio of the Aid flow from UN agencies (US$) of Guatemala in 1994 to that in 1995?
Offer a very short reply. 3.68. What is the ratio of the Aid flow from UN agencies (US$) of Thailand in 1994 to that in 1995?
Your response must be concise. 0.87. What is the ratio of the Aid flow from UN agencies (US$) of Congo (Republic) in 1994 to that in 1996?
Your answer should be very brief. 1.95. What is the ratio of the Aid flow from UN agencies (US$) in Cuba in 1994 to that in 1996?
Ensure brevity in your answer.  2.14. What is the ratio of the Aid flow from UN agencies (US$) of Guatemala in 1994 to that in 1996?
Provide a succinct answer. 0.91. What is the ratio of the Aid flow from UN agencies (US$) of Thailand in 1994 to that in 1996?
Offer a terse response. 0.69. What is the ratio of the Aid flow from UN agencies (US$) in Congo (Republic) in 1994 to that in 1997?
Keep it short and to the point. 4.93. What is the ratio of the Aid flow from UN agencies (US$) of Cuba in 1994 to that in 1997?
Offer a terse response. 1.31. What is the ratio of the Aid flow from UN agencies (US$) of Guatemala in 1994 to that in 1997?
Offer a terse response. 0.35. What is the ratio of the Aid flow from UN agencies (US$) of Congo (Republic) in 1994 to that in 1998?
Your answer should be very brief. 1.1. What is the ratio of the Aid flow from UN agencies (US$) in Cuba in 1994 to that in 1998?
Offer a terse response. 2.07. What is the ratio of the Aid flow from UN agencies (US$) in Guatemala in 1994 to that in 1998?
Your answer should be very brief. 0.31. What is the ratio of the Aid flow from UN agencies (US$) of Congo (Republic) in 1994 to that in 1999?
Provide a succinct answer. 6.73. What is the ratio of the Aid flow from UN agencies (US$) of Cuba in 1994 to that in 1999?
Provide a succinct answer. 1.99. What is the ratio of the Aid flow from UN agencies (US$) in Guatemala in 1994 to that in 1999?
Keep it short and to the point. 2.89. What is the ratio of the Aid flow from UN agencies (US$) in Thailand in 1994 to that in 1999?
Offer a terse response. 1.31. What is the ratio of the Aid flow from UN agencies (US$) in Congo (Republic) in 1995 to that in 1996?
Your answer should be very brief. 1.79. What is the ratio of the Aid flow from UN agencies (US$) in Cuba in 1995 to that in 1996?
Offer a very short reply. 1.79. What is the ratio of the Aid flow from UN agencies (US$) of Guatemala in 1995 to that in 1996?
Make the answer very short. 0.25. What is the ratio of the Aid flow from UN agencies (US$) of Thailand in 1995 to that in 1996?
Provide a short and direct response. 0.8. What is the ratio of the Aid flow from UN agencies (US$) in Congo (Republic) in 1995 to that in 1997?
Make the answer very short. 4.53. What is the ratio of the Aid flow from UN agencies (US$) of Cuba in 1995 to that in 1997?
Provide a succinct answer. 1.1. What is the ratio of the Aid flow from UN agencies (US$) of Guatemala in 1995 to that in 1997?
Your answer should be compact. 0.09. What is the ratio of the Aid flow from UN agencies (US$) of Thailand in 1995 to that in 1997?
Offer a very short reply. 0.77. What is the ratio of the Aid flow from UN agencies (US$) in Congo (Republic) in 1995 to that in 1998?
Your response must be concise. 1.01. What is the ratio of the Aid flow from UN agencies (US$) in Cuba in 1995 to that in 1998?
Your answer should be very brief. 1.73. What is the ratio of the Aid flow from UN agencies (US$) in Guatemala in 1995 to that in 1998?
Ensure brevity in your answer.  0.08. What is the ratio of the Aid flow from UN agencies (US$) in Thailand in 1995 to that in 1998?
Provide a succinct answer. 1.54. What is the ratio of the Aid flow from UN agencies (US$) in Congo (Republic) in 1995 to that in 1999?
Your response must be concise. 6.18. What is the ratio of the Aid flow from UN agencies (US$) in Cuba in 1995 to that in 1999?
Your response must be concise. 1.66. What is the ratio of the Aid flow from UN agencies (US$) in Guatemala in 1995 to that in 1999?
Ensure brevity in your answer.  0.79. What is the ratio of the Aid flow from UN agencies (US$) in Thailand in 1995 to that in 1999?
Offer a terse response. 1.51. What is the ratio of the Aid flow from UN agencies (US$) of Congo (Republic) in 1996 to that in 1997?
Ensure brevity in your answer.  2.53. What is the ratio of the Aid flow from UN agencies (US$) in Cuba in 1996 to that in 1997?
Give a very brief answer. 0.61. What is the ratio of the Aid flow from UN agencies (US$) of Guatemala in 1996 to that in 1997?
Offer a very short reply. 0.38. What is the ratio of the Aid flow from UN agencies (US$) in Thailand in 1996 to that in 1997?
Offer a very short reply. 0.96. What is the ratio of the Aid flow from UN agencies (US$) in Congo (Republic) in 1996 to that in 1998?
Provide a succinct answer. 0.57. What is the ratio of the Aid flow from UN agencies (US$) in Cuba in 1996 to that in 1998?
Your answer should be compact. 0.97. What is the ratio of the Aid flow from UN agencies (US$) of Guatemala in 1996 to that in 1998?
Give a very brief answer. 0.34. What is the ratio of the Aid flow from UN agencies (US$) of Thailand in 1996 to that in 1998?
Make the answer very short. 1.92. What is the ratio of the Aid flow from UN agencies (US$) of Congo (Republic) in 1996 to that in 1999?
Make the answer very short. 3.45. What is the ratio of the Aid flow from UN agencies (US$) of Cuba in 1996 to that in 1999?
Give a very brief answer. 0.93. What is the ratio of the Aid flow from UN agencies (US$) in Guatemala in 1996 to that in 1999?
Provide a short and direct response. 3.17. What is the ratio of the Aid flow from UN agencies (US$) of Thailand in 1996 to that in 1999?
Offer a terse response. 1.88. What is the ratio of the Aid flow from UN agencies (US$) in Congo (Republic) in 1997 to that in 1998?
Your answer should be very brief. 0.22. What is the ratio of the Aid flow from UN agencies (US$) in Cuba in 1997 to that in 1998?
Your response must be concise. 1.58. What is the ratio of the Aid flow from UN agencies (US$) in Guatemala in 1997 to that in 1998?
Your answer should be compact. 0.89. What is the ratio of the Aid flow from UN agencies (US$) in Congo (Republic) in 1997 to that in 1999?
Your answer should be very brief. 1.36. What is the ratio of the Aid flow from UN agencies (US$) in Cuba in 1997 to that in 1999?
Keep it short and to the point. 1.51. What is the ratio of the Aid flow from UN agencies (US$) in Guatemala in 1997 to that in 1999?
Keep it short and to the point. 8.38. What is the ratio of the Aid flow from UN agencies (US$) in Thailand in 1997 to that in 1999?
Keep it short and to the point. 1.96. What is the ratio of the Aid flow from UN agencies (US$) in Congo (Republic) in 1998 to that in 1999?
Your answer should be very brief. 6.09. What is the ratio of the Aid flow from UN agencies (US$) in Cuba in 1998 to that in 1999?
Your response must be concise. 0.96. What is the ratio of the Aid flow from UN agencies (US$) of Guatemala in 1998 to that in 1999?
Your response must be concise. 9.43. What is the ratio of the Aid flow from UN agencies (US$) of Thailand in 1998 to that in 1999?
Keep it short and to the point. 0.98. What is the difference between the highest and the second highest Aid flow from UN agencies (US$) in Cuba?
Make the answer very short. 5.20e+05. What is the difference between the highest and the lowest Aid flow from UN agencies (US$) of Congo (Republic)?
Your response must be concise. 6.50e+05. What is the difference between the highest and the lowest Aid flow from UN agencies (US$) of Cuba?
Offer a very short reply. 1.76e+06. What is the difference between the highest and the lowest Aid flow from UN agencies (US$) of Guatemala?
Give a very brief answer. 4.06e+06. What is the difference between the highest and the lowest Aid flow from UN agencies (US$) of Thailand?
Ensure brevity in your answer.  2.10e+06. 